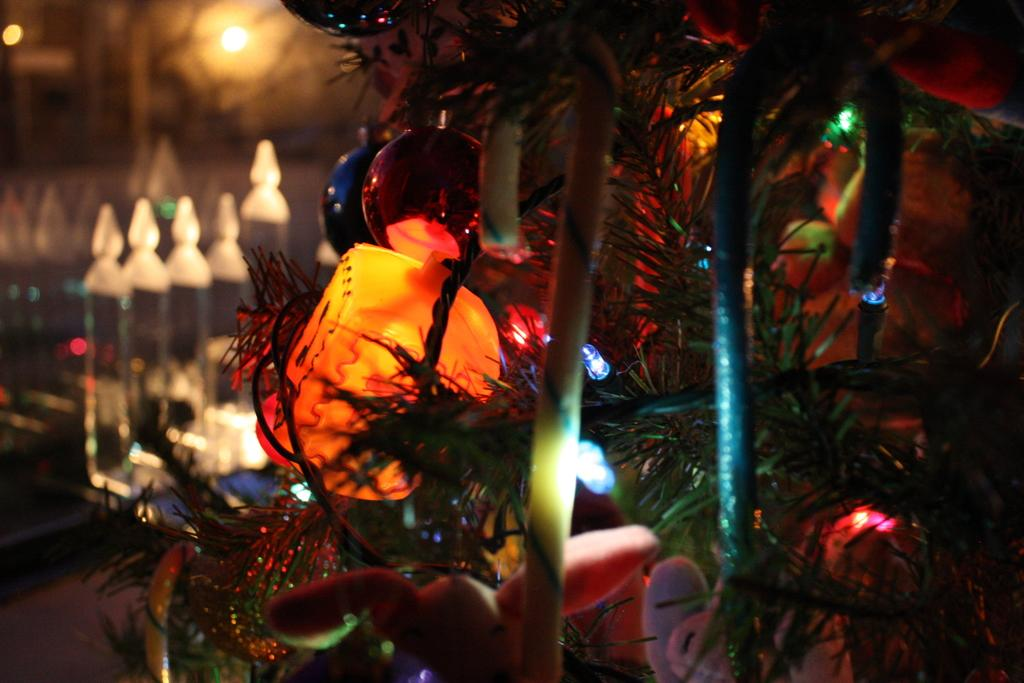What type of tree is in the image? There is a Christmas tree in the image. What decorations can be seen on the Christmas tree? The Christmas tree has colorful balls and lights. Are there any other objects on the Christmas tree? Yes, there are objects on the Christmas tree. How is the back side of the image? The back side of the image is blurred. What type of behavior is being protested in the image? There is no protest or behavior being depicted in the image; it features a Christmas tree with decorations. Who is the representative in the image? There is no representative present in the image; it only shows a Christmas tree. 